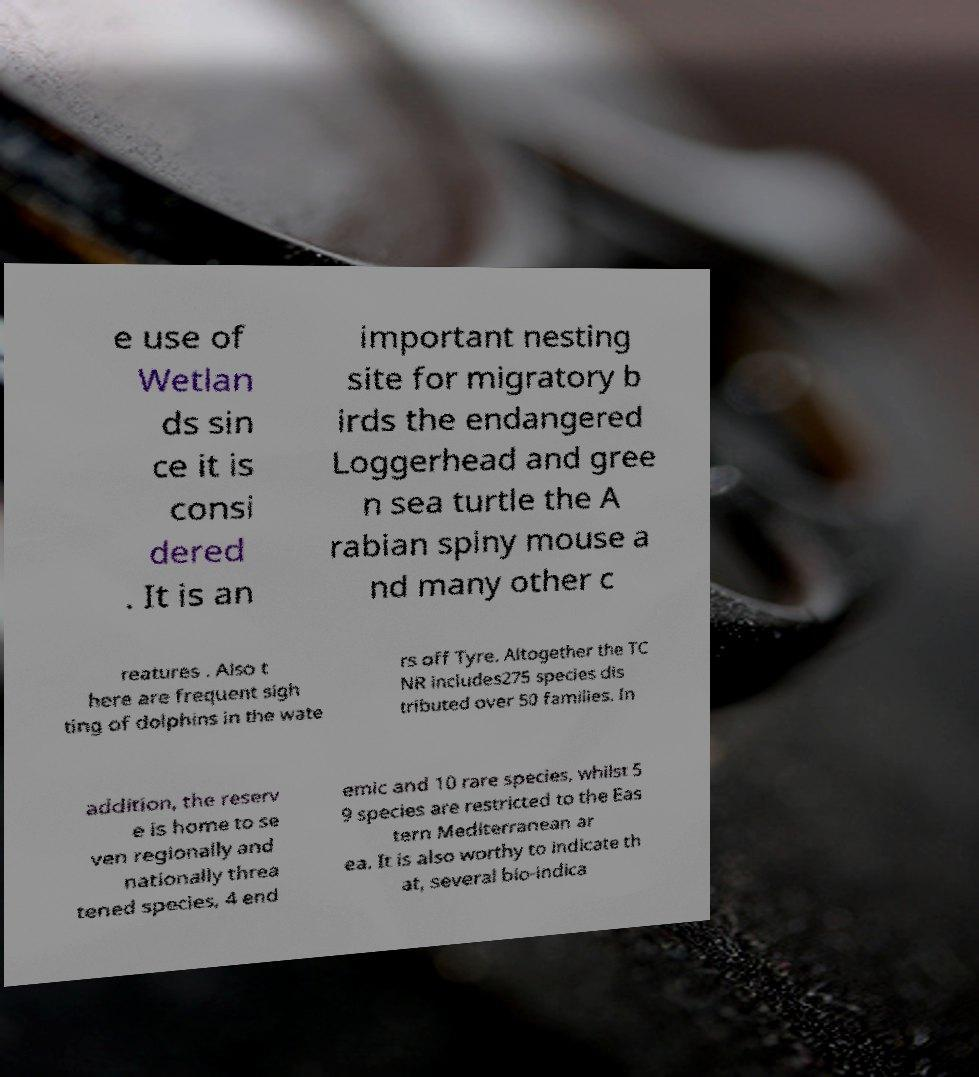I need the written content from this picture converted into text. Can you do that? e use of Wetlan ds sin ce it is consi dered . It is an important nesting site for migratory b irds the endangered Loggerhead and gree n sea turtle the A rabian spiny mouse a nd many other c reatures . Also t here are frequent sigh ting of dolphins in the wate rs off Tyre. Altogether the TC NR includes275 species dis tributed over 50 families. In addition, the reserv e is home to se ven regionally and nationally threa tened species, 4 end emic and 10 rare species, whilst 5 9 species are restricted to the Eas tern Mediterranean ar ea. It is also worthy to indicate th at, several bio-indica 